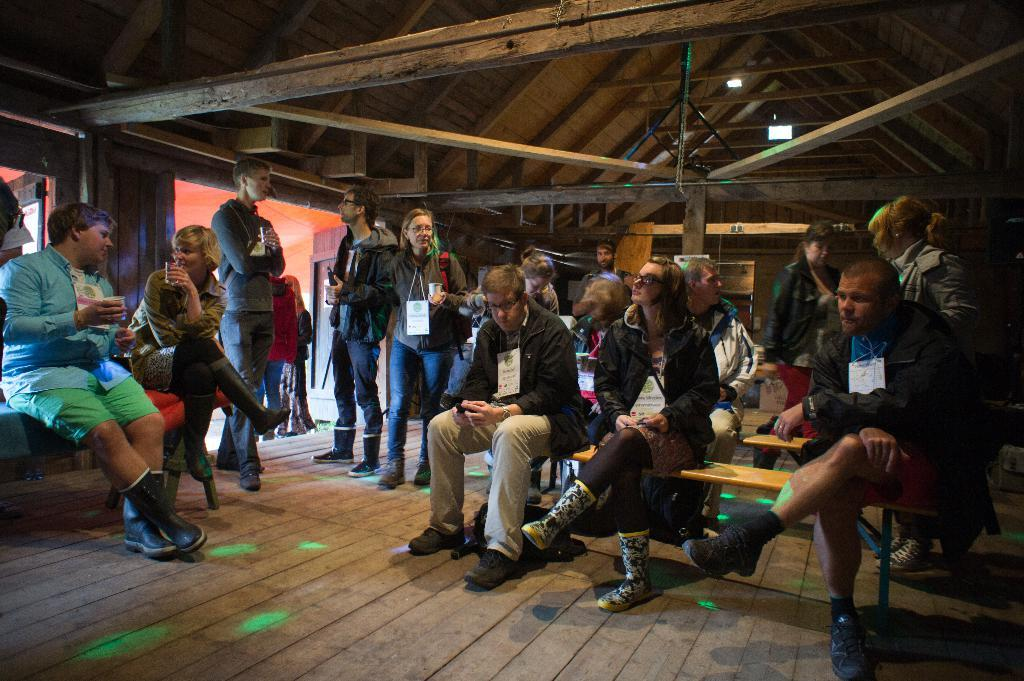What material is the room made of? The room is made of wood. What is happening inside the room? There is a group of people inside the room, and they are discussing with each other. Can you describe the position of some people in the room? Some people are standing at the entrance of the room. What type of jewel is being passed around by the people in the room? There is no mention of a jewel in the image, and no such activity is taking place. 